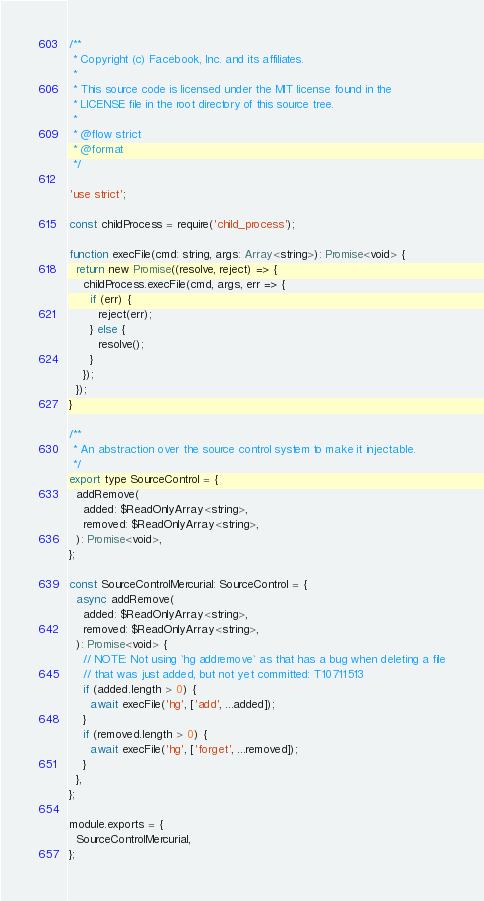<code> <loc_0><loc_0><loc_500><loc_500><_JavaScript_>/**
 * Copyright (c) Facebook, Inc. and its affiliates.
 *
 * This source code is licensed under the MIT license found in the
 * LICENSE file in the root directory of this source tree.
 *
 * @flow strict
 * @format
 */

'use strict';

const childProcess = require('child_process');

function execFile(cmd: string, args: Array<string>): Promise<void> {
  return new Promise((resolve, reject) => {
    childProcess.execFile(cmd, args, err => {
      if (err) {
        reject(err);
      } else {
        resolve();
      }
    });
  });
}

/**
 * An abstraction over the source control system to make it injectable.
 */
export type SourceControl = {
  addRemove(
    added: $ReadOnlyArray<string>,
    removed: $ReadOnlyArray<string>,
  ): Promise<void>,
};

const SourceControlMercurial: SourceControl = {
  async addRemove(
    added: $ReadOnlyArray<string>,
    removed: $ReadOnlyArray<string>,
  ): Promise<void> {
    // NOTE: Not using `hg addremove` as that has a bug when deleting a file
    // that was just added, but not yet committed: T10711513
    if (added.length > 0) {
      await execFile('hg', ['add', ...added]);
    }
    if (removed.length > 0) {
      await execFile('hg', ['forget', ...removed]);
    }
  },
};

module.exports = {
  SourceControlMercurial,
};
</code> 